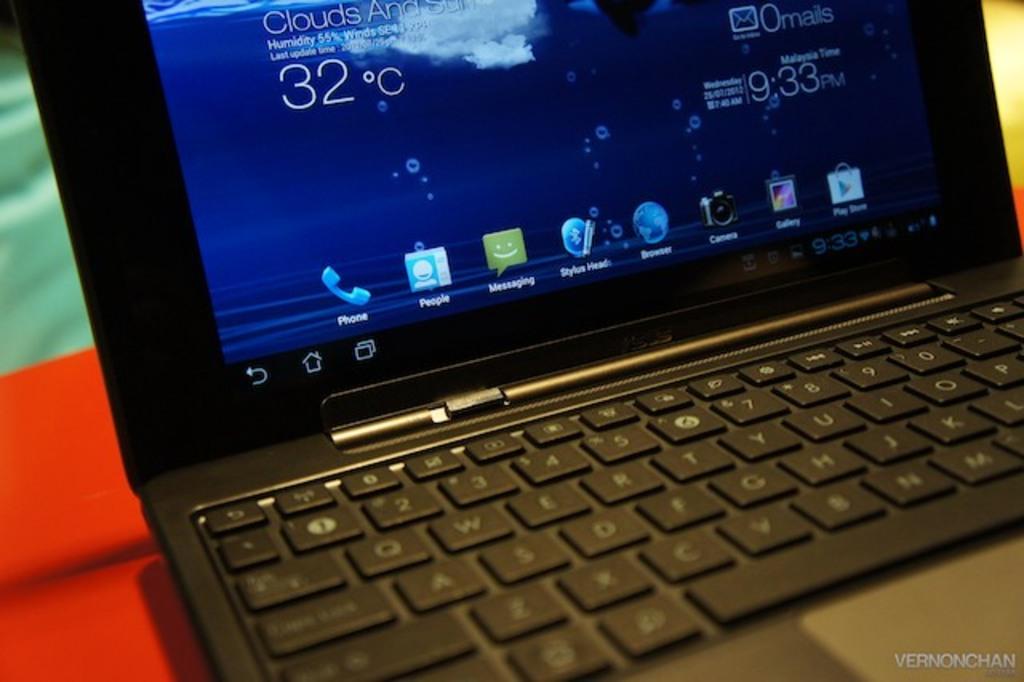What is the temperature?
Provide a short and direct response. 32. What doing in laptop?
Your response must be concise. Unanswerable. 